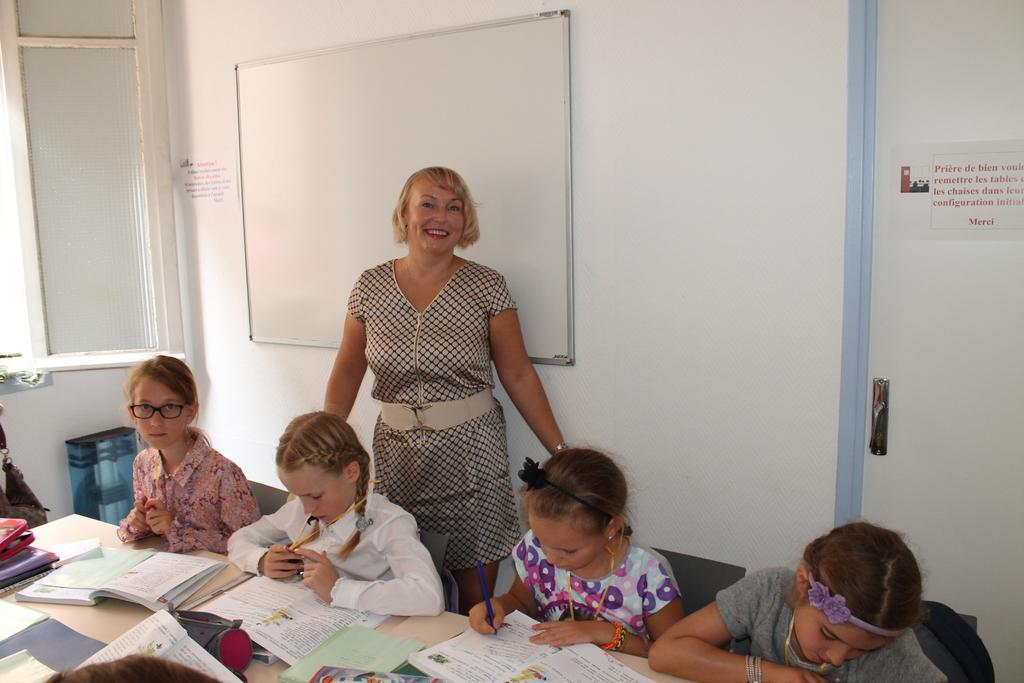How many kids are present in the image? There are four kids in the image. What are the kids doing in the image? The kids are sitting in chairs. What is in front of the kids? There is a table in front of the kids. What is on the table? The table has books on it. Who is standing behind the kids? There is a woman standing behind the kids. Can you see the river flowing behind the kids in the image? There is no river visible in the image. What type of bag is the woman carrying in the image? The woman is not carrying a bag in the image. 